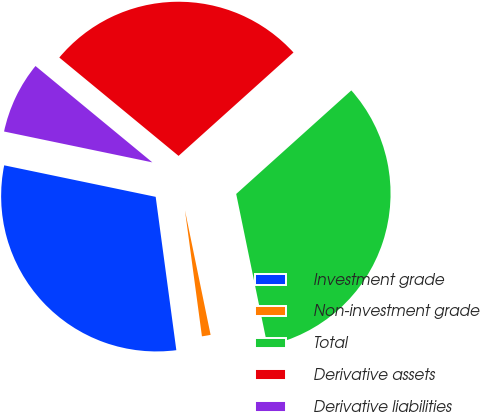Convert chart to OTSL. <chart><loc_0><loc_0><loc_500><loc_500><pie_chart><fcel>Investment grade<fcel>Non-investment grade<fcel>Total<fcel>Derivative assets<fcel>Derivative liabilities<nl><fcel>30.4%<fcel>1.1%<fcel>33.43%<fcel>27.37%<fcel>7.71%<nl></chart> 